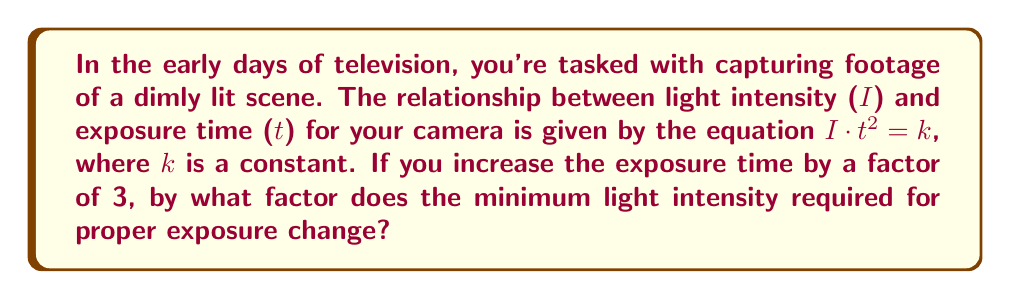Show me your answer to this math problem. Let's approach this step-by-step:

1) The initial relationship is given by:
   $I_1 \cdot t_1^2 = k$

2) After increasing the exposure time by a factor of 3, we have:
   $I_2 \cdot (3t_1)^2 = k$

3) Expand the squared term:
   $I_2 \cdot 9t_1^2 = k$

4) Since both equations equal k, we can set them equal to each other:
   $I_1 \cdot t_1^2 = I_2 \cdot 9t_1^2$

5) Cancel out $t_1^2$ from both sides:
   $I_1 = 9I_2$

6) Divide both sides by $I_2$:
   $\frac{I_1}{I_2} = 9$

7) This ratio tells us that $I_1$ is 9 times $I_2$, or in other words, $I_2$ is $\frac{1}{9}$ of $I_1$.

Therefore, when the exposure time is increased by a factor of 3, the minimum light intensity required for proper exposure decreases by a factor of 9, or to $\frac{1}{9}$ of its original value.
Answer: The minimum light intensity required for proper exposure changes by a factor of $\frac{1}{9}$. 